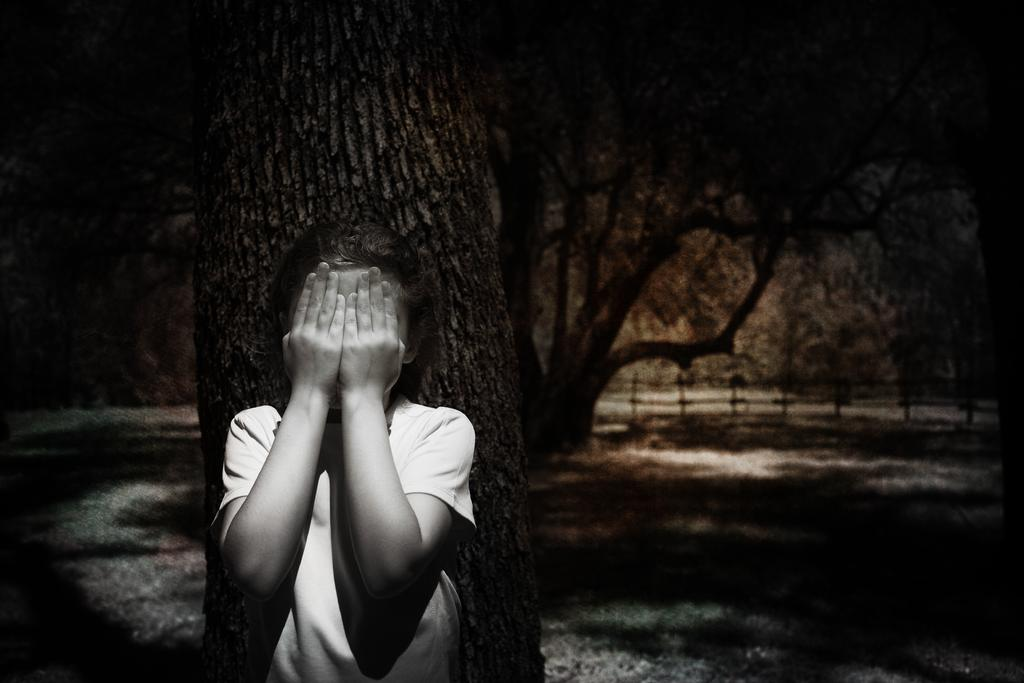Where was the image taken? The image was clicked outside. What can be seen in the middle of the image? There are trees and a kid in the middle of the image. What type of harmony is being played by the maid in the image? There is no maid or harmony present in the image. How many beads are visible on the kid's necklace in the image? There is no necklace or beads visible on the kid in the image. 